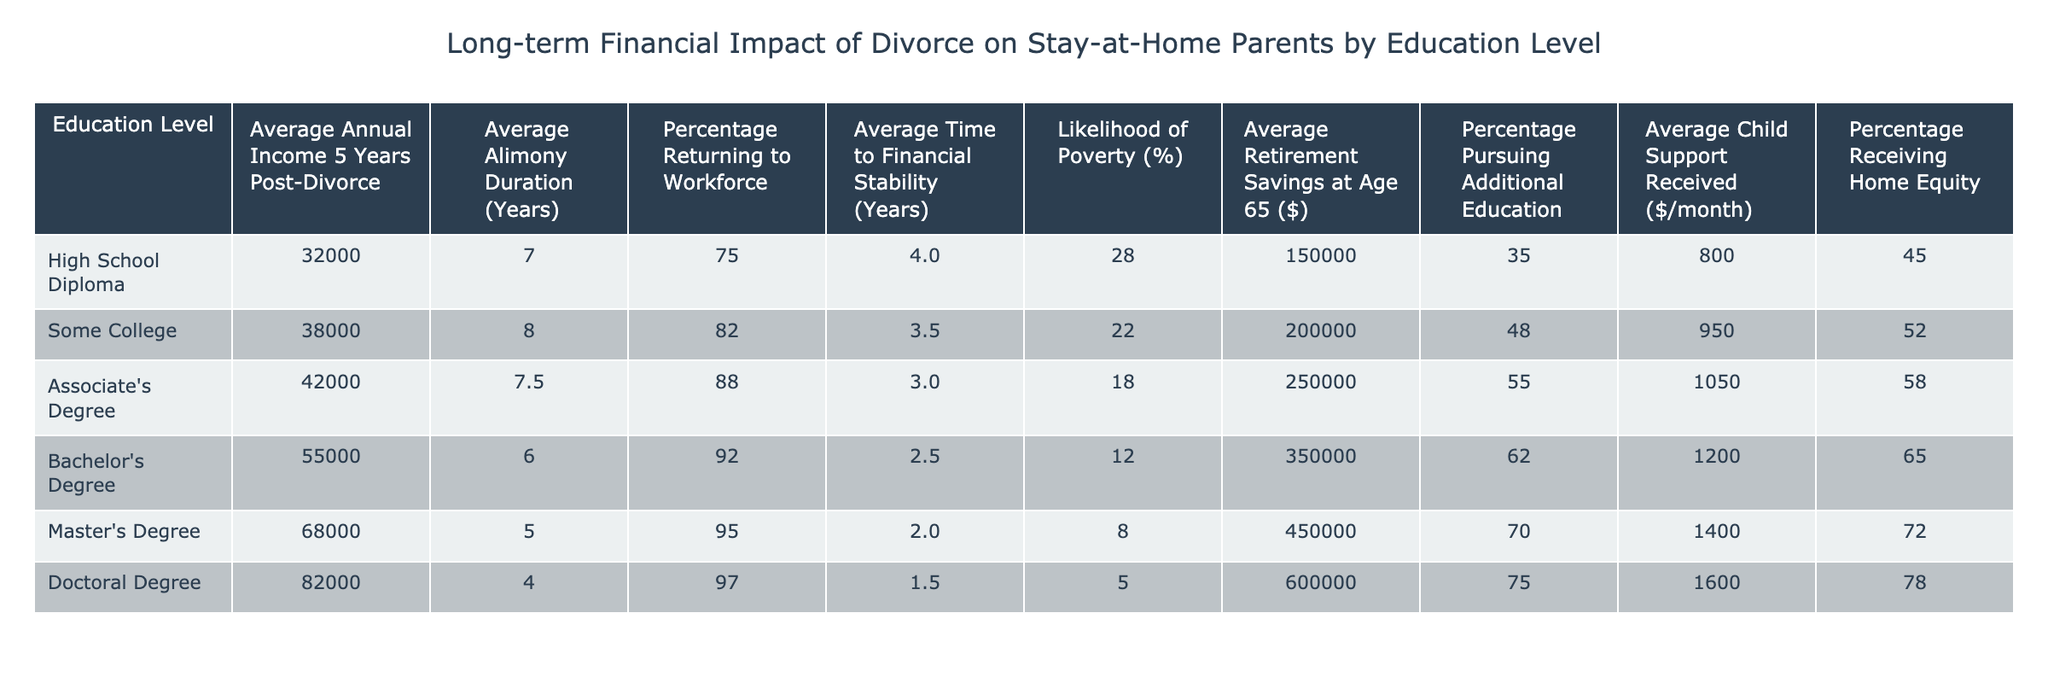What is the average annual income for someone with a Bachelor's Degree five years post-divorce? Referring to the table, the value under "Average Annual Income 5 Years Post-Divorce" for "Bachelor's Degree" is $55,000.
Answer: $55,000 What percentage of stay-at-home parents with a Master's Degree are likely to return to the workforce? Looking at the column for "Percentage Returning to Workforce," the value for "Master's Degree" is 95%.
Answer: 95% What is the likelihood of poverty for individuals with an Associate's Degree post-divorce? By checking the table, the "Likelihood of Poverty (%)" for "Associate's Degree" is 18%.
Answer: 18% What is the difference in average annual income five years post-divorce between those with a Doctoral Degree and those with a High School Diploma? The average annual income for a Doctoral Degree is $82,000 and for a High School Diploma is $32,000. The difference is $82,000 - $32,000 = $50,000.
Answer: $50,000 Calculate the average time to financial stability for all education levels. The average time to financial stability can be calculated by summing all values: (4 + 3.5 + 3 + 2.5 + 2 + 1.5) = 16.5 years; then divide by the number of education levels (6). Thus, the average is 16.5 / 6 = 2.75 years.
Answer: 2.75 years Is the average child support received higher for those with an Associate's Degree than for those with a High School Diploma? The average child support for "Associate's Degree" is $1,050 and for "High School Diploma" is $800. Since $1,050 is greater than $800, the statement is true.
Answer: Yes What is the relationship between education level and average retirement savings at age 65? By comparing the values, we can see that as education level increases from High School Diploma to Doctoral Degree, the average retirement savings also increases: from $150,000 to $600,000. This indicates a positive relationship between education level and retirement savings.
Answer: Positive relationship How does the average alimony duration for a Master's Degree compare to that for a Bachelor's Degree? The average alimony duration for a Master's Degree is 5 years, while for a Bachelor's Degree, it is 6 years. Therefore, a Master's Degree has a shorter average duration.
Answer: Shorter If a stay-at-home parent with a Master's Degree has an average retirement savings of $450,000, what is the percentage increase in retirement savings compared to someone with a High School Diploma? For High School Diploma, the average retirement savings is $150,000. The increase is $450,000 - $150,000 = $300,000. To find the percentage increase, divide the increase by the initial amount: ($300,000 / $150,000) * 100 = 200%.
Answer: 200% Which education level has the highest average retirement savings at age 65? The table indicates that a Doctoral Degree has the highest average retirement savings at $600,000.
Answer: Doctoral Degree 